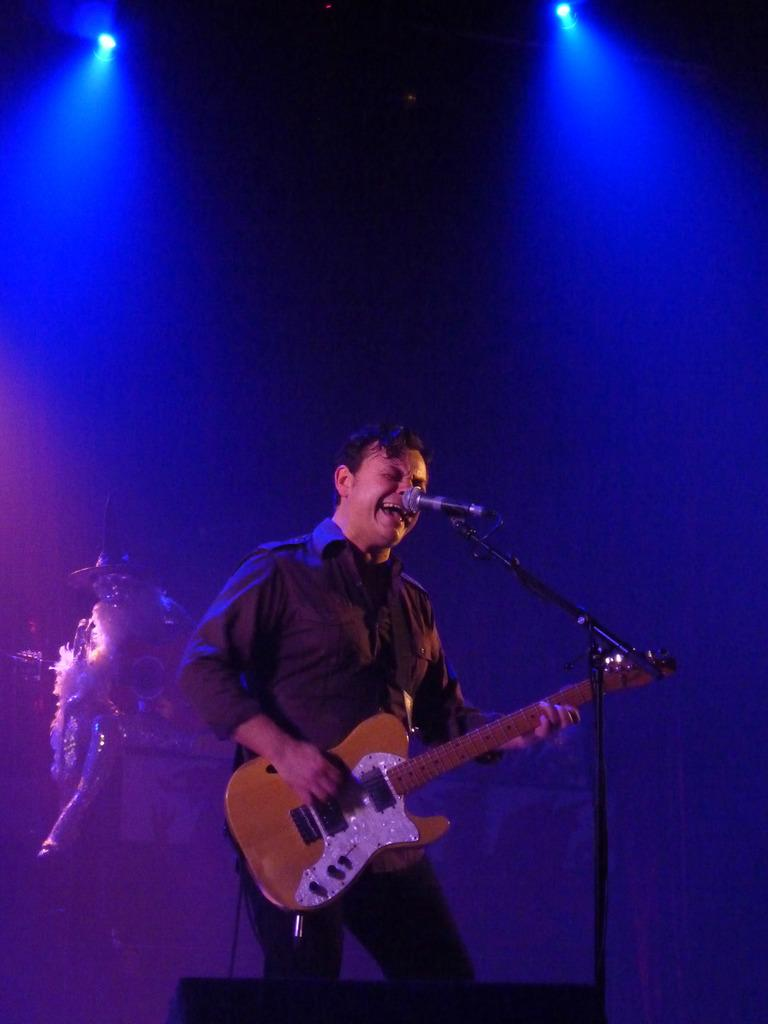What is the person in the image holding? The person is holding a guitar in their hands. What can be seen near the person in the image? There is a microphone and a microphone stand in the image. What other object is present in the image? There is a cable in the image. What type of lighting is visible in the image? There are electric lights in the image. Can you describe the person's shadow in the image? There is a person's shadow in the image. What time of day is it in the image, given the presence of morning light? The presence of electric lights in the image suggests that it is not morning, and there is no indication of the time of day. What type of collar is the person wearing in the image? There is no collar visible on the person in the image. 